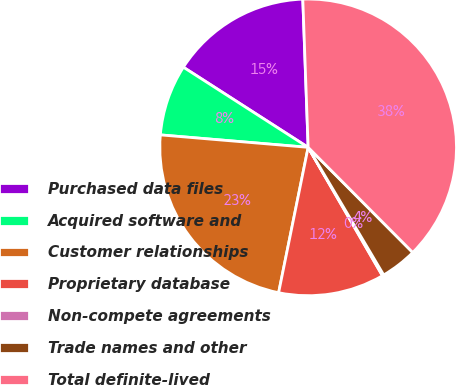Convert chart to OTSL. <chart><loc_0><loc_0><loc_500><loc_500><pie_chart><fcel>Purchased data files<fcel>Acquired software and<fcel>Customer relationships<fcel>Proprietary database<fcel>Non-compete agreements<fcel>Trade names and other<fcel>Total definite-lived<nl><fcel>15.34%<fcel>7.75%<fcel>23.15%<fcel>11.54%<fcel>0.16%<fcel>3.95%<fcel>38.12%<nl></chart> 